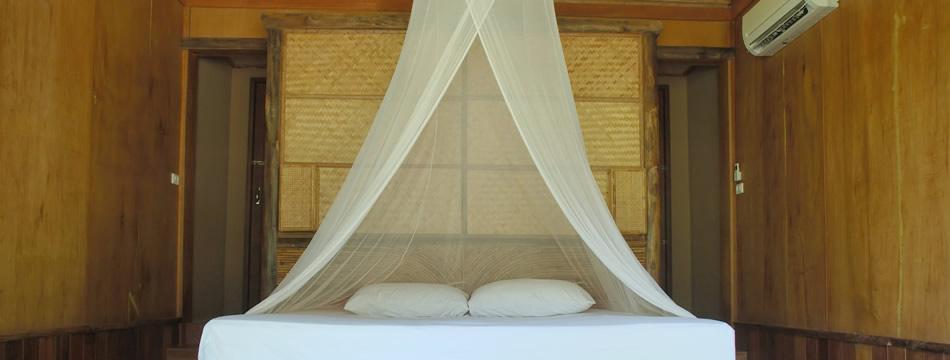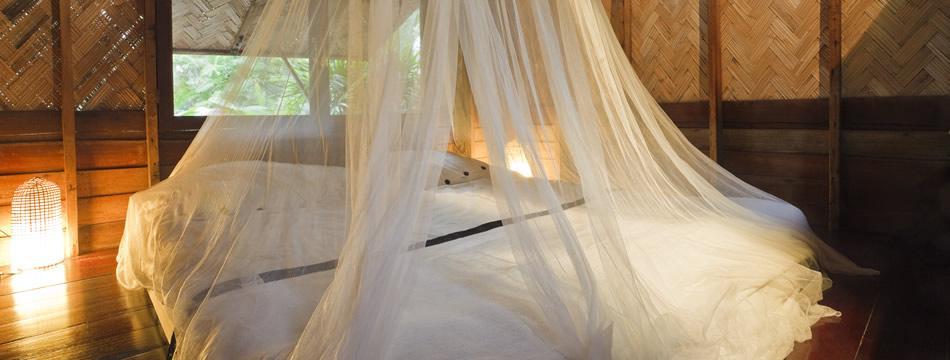The first image is the image on the left, the second image is the image on the right. Analyze the images presented: Is the assertion "Two blue pillows are on a bed under a sheer white canopy that ties at the corners." valid? Answer yes or no. No. The first image is the image on the left, the second image is the image on the right. Considering the images on both sides, is "There is no more than 5 pillows." valid? Answer yes or no. Yes. 